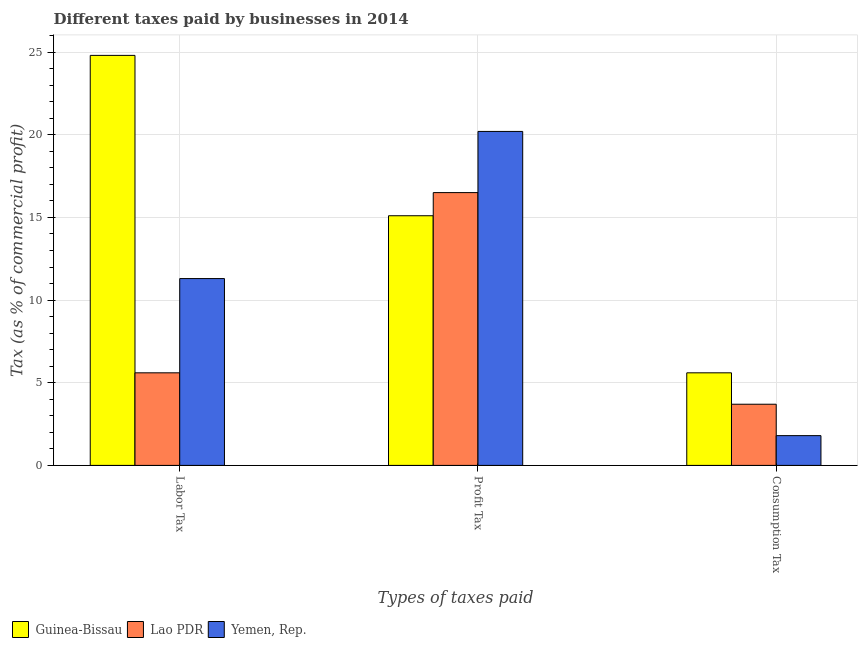How many different coloured bars are there?
Offer a very short reply. 3. Are the number of bars per tick equal to the number of legend labels?
Ensure brevity in your answer.  Yes. Are the number of bars on each tick of the X-axis equal?
Keep it short and to the point. Yes. How many bars are there on the 3rd tick from the left?
Your answer should be compact. 3. What is the label of the 3rd group of bars from the left?
Make the answer very short. Consumption Tax. What is the percentage of labor tax in Guinea-Bissau?
Offer a very short reply. 24.8. Across all countries, what is the maximum percentage of labor tax?
Provide a short and direct response. 24.8. Across all countries, what is the minimum percentage of profit tax?
Your answer should be very brief. 15.1. In which country was the percentage of labor tax maximum?
Make the answer very short. Guinea-Bissau. In which country was the percentage of profit tax minimum?
Offer a terse response. Guinea-Bissau. What is the total percentage of profit tax in the graph?
Your response must be concise. 51.8. What is the difference between the percentage of labor tax in Lao PDR and that in Guinea-Bissau?
Your response must be concise. -19.2. What is the average percentage of labor tax per country?
Make the answer very short. 13.9. What is the difference between the percentage of labor tax and percentage of consumption tax in Yemen, Rep.?
Provide a succinct answer. 9.5. What is the ratio of the percentage of labor tax in Lao PDR to that in Yemen, Rep.?
Keep it short and to the point. 0.5. What is the difference between the highest and the second highest percentage of consumption tax?
Offer a very short reply. 1.9. What is the difference between the highest and the lowest percentage of labor tax?
Make the answer very short. 19.2. In how many countries, is the percentage of profit tax greater than the average percentage of profit tax taken over all countries?
Your answer should be compact. 1. Is the sum of the percentage of labor tax in Yemen, Rep. and Lao PDR greater than the maximum percentage of consumption tax across all countries?
Your answer should be very brief. Yes. What does the 2nd bar from the left in Consumption Tax represents?
Make the answer very short. Lao PDR. What does the 2nd bar from the right in Labor Tax represents?
Offer a very short reply. Lao PDR. Is it the case that in every country, the sum of the percentage of labor tax and percentage of profit tax is greater than the percentage of consumption tax?
Provide a short and direct response. Yes. How many bars are there?
Provide a short and direct response. 9. How many countries are there in the graph?
Offer a terse response. 3. What is the difference between two consecutive major ticks on the Y-axis?
Make the answer very short. 5. Does the graph contain any zero values?
Offer a terse response. No. How many legend labels are there?
Provide a short and direct response. 3. What is the title of the graph?
Offer a terse response. Different taxes paid by businesses in 2014. Does "Swaziland" appear as one of the legend labels in the graph?
Provide a succinct answer. No. What is the label or title of the X-axis?
Your response must be concise. Types of taxes paid. What is the label or title of the Y-axis?
Provide a short and direct response. Tax (as % of commercial profit). What is the Tax (as % of commercial profit) of Guinea-Bissau in Labor Tax?
Keep it short and to the point. 24.8. What is the Tax (as % of commercial profit) in Yemen, Rep. in Labor Tax?
Make the answer very short. 11.3. What is the Tax (as % of commercial profit) in Yemen, Rep. in Profit Tax?
Make the answer very short. 20.2. What is the Tax (as % of commercial profit) in Guinea-Bissau in Consumption Tax?
Make the answer very short. 5.6. What is the Tax (as % of commercial profit) in Yemen, Rep. in Consumption Tax?
Your response must be concise. 1.8. Across all Types of taxes paid, what is the maximum Tax (as % of commercial profit) in Guinea-Bissau?
Provide a short and direct response. 24.8. Across all Types of taxes paid, what is the maximum Tax (as % of commercial profit) in Lao PDR?
Ensure brevity in your answer.  16.5. Across all Types of taxes paid, what is the maximum Tax (as % of commercial profit) of Yemen, Rep.?
Offer a very short reply. 20.2. Across all Types of taxes paid, what is the minimum Tax (as % of commercial profit) in Yemen, Rep.?
Keep it short and to the point. 1.8. What is the total Tax (as % of commercial profit) in Guinea-Bissau in the graph?
Provide a succinct answer. 45.5. What is the total Tax (as % of commercial profit) of Lao PDR in the graph?
Offer a very short reply. 25.8. What is the total Tax (as % of commercial profit) of Yemen, Rep. in the graph?
Provide a succinct answer. 33.3. What is the difference between the Tax (as % of commercial profit) in Guinea-Bissau in Labor Tax and that in Profit Tax?
Your answer should be very brief. 9.7. What is the difference between the Tax (as % of commercial profit) of Lao PDR in Labor Tax and that in Profit Tax?
Your answer should be very brief. -10.9. What is the difference between the Tax (as % of commercial profit) in Yemen, Rep. in Labor Tax and that in Profit Tax?
Provide a short and direct response. -8.9. What is the difference between the Tax (as % of commercial profit) of Guinea-Bissau in Labor Tax and that in Consumption Tax?
Your answer should be compact. 19.2. What is the difference between the Tax (as % of commercial profit) in Lao PDR in Labor Tax and that in Consumption Tax?
Provide a short and direct response. 1.9. What is the difference between the Tax (as % of commercial profit) of Lao PDR in Profit Tax and that in Consumption Tax?
Provide a short and direct response. 12.8. What is the difference between the Tax (as % of commercial profit) of Yemen, Rep. in Profit Tax and that in Consumption Tax?
Provide a short and direct response. 18.4. What is the difference between the Tax (as % of commercial profit) of Guinea-Bissau in Labor Tax and the Tax (as % of commercial profit) of Yemen, Rep. in Profit Tax?
Keep it short and to the point. 4.6. What is the difference between the Tax (as % of commercial profit) of Lao PDR in Labor Tax and the Tax (as % of commercial profit) of Yemen, Rep. in Profit Tax?
Your response must be concise. -14.6. What is the difference between the Tax (as % of commercial profit) in Guinea-Bissau in Labor Tax and the Tax (as % of commercial profit) in Lao PDR in Consumption Tax?
Keep it short and to the point. 21.1. What is the difference between the Tax (as % of commercial profit) of Lao PDR in Labor Tax and the Tax (as % of commercial profit) of Yemen, Rep. in Consumption Tax?
Give a very brief answer. 3.8. What is the difference between the Tax (as % of commercial profit) in Guinea-Bissau in Profit Tax and the Tax (as % of commercial profit) in Yemen, Rep. in Consumption Tax?
Give a very brief answer. 13.3. What is the average Tax (as % of commercial profit) in Guinea-Bissau per Types of taxes paid?
Offer a terse response. 15.17. What is the average Tax (as % of commercial profit) in Yemen, Rep. per Types of taxes paid?
Your answer should be compact. 11.1. What is the difference between the Tax (as % of commercial profit) of Guinea-Bissau and Tax (as % of commercial profit) of Lao PDR in Labor Tax?
Offer a very short reply. 19.2. What is the difference between the Tax (as % of commercial profit) of Guinea-Bissau and Tax (as % of commercial profit) of Yemen, Rep. in Labor Tax?
Your answer should be compact. 13.5. What is the difference between the Tax (as % of commercial profit) in Guinea-Bissau and Tax (as % of commercial profit) in Yemen, Rep. in Profit Tax?
Your answer should be very brief. -5.1. What is the difference between the Tax (as % of commercial profit) in Guinea-Bissau and Tax (as % of commercial profit) in Yemen, Rep. in Consumption Tax?
Keep it short and to the point. 3.8. What is the difference between the Tax (as % of commercial profit) of Lao PDR and Tax (as % of commercial profit) of Yemen, Rep. in Consumption Tax?
Offer a very short reply. 1.9. What is the ratio of the Tax (as % of commercial profit) in Guinea-Bissau in Labor Tax to that in Profit Tax?
Your response must be concise. 1.64. What is the ratio of the Tax (as % of commercial profit) of Lao PDR in Labor Tax to that in Profit Tax?
Ensure brevity in your answer.  0.34. What is the ratio of the Tax (as % of commercial profit) of Yemen, Rep. in Labor Tax to that in Profit Tax?
Offer a very short reply. 0.56. What is the ratio of the Tax (as % of commercial profit) of Guinea-Bissau in Labor Tax to that in Consumption Tax?
Keep it short and to the point. 4.43. What is the ratio of the Tax (as % of commercial profit) of Lao PDR in Labor Tax to that in Consumption Tax?
Offer a very short reply. 1.51. What is the ratio of the Tax (as % of commercial profit) in Yemen, Rep. in Labor Tax to that in Consumption Tax?
Offer a terse response. 6.28. What is the ratio of the Tax (as % of commercial profit) of Guinea-Bissau in Profit Tax to that in Consumption Tax?
Provide a succinct answer. 2.7. What is the ratio of the Tax (as % of commercial profit) in Lao PDR in Profit Tax to that in Consumption Tax?
Make the answer very short. 4.46. What is the ratio of the Tax (as % of commercial profit) of Yemen, Rep. in Profit Tax to that in Consumption Tax?
Your answer should be very brief. 11.22. What is the difference between the highest and the second highest Tax (as % of commercial profit) of Lao PDR?
Give a very brief answer. 10.9. What is the difference between the highest and the second highest Tax (as % of commercial profit) of Yemen, Rep.?
Ensure brevity in your answer.  8.9. What is the difference between the highest and the lowest Tax (as % of commercial profit) in Guinea-Bissau?
Offer a very short reply. 19.2. What is the difference between the highest and the lowest Tax (as % of commercial profit) of Lao PDR?
Provide a succinct answer. 12.8. What is the difference between the highest and the lowest Tax (as % of commercial profit) in Yemen, Rep.?
Provide a succinct answer. 18.4. 